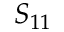<formula> <loc_0><loc_0><loc_500><loc_500>S _ { 1 1 }</formula> 